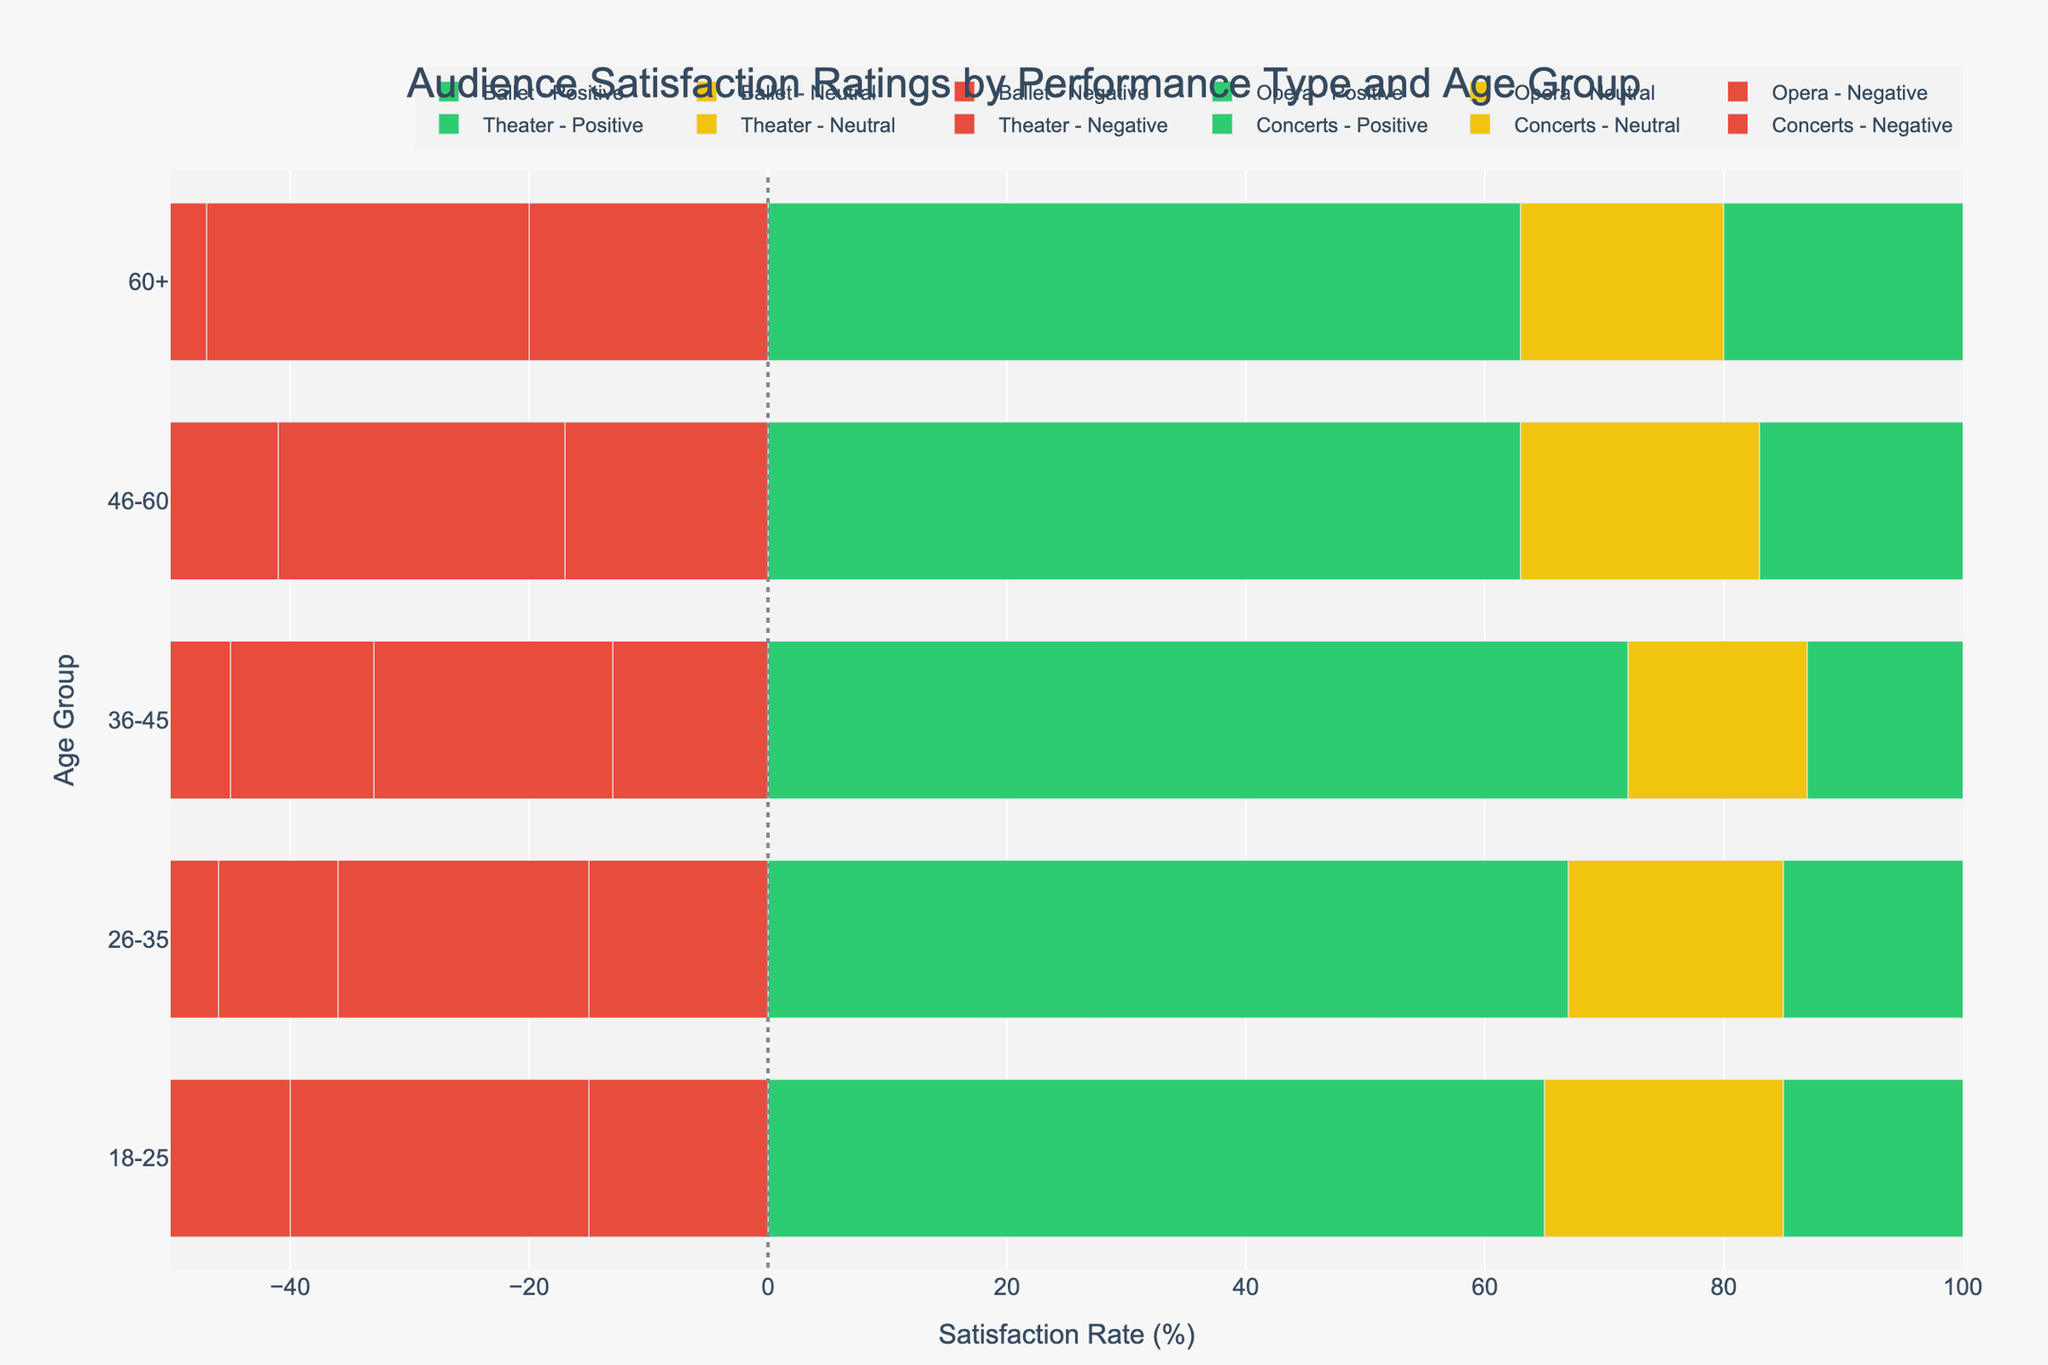Which age group has the highest satisfaction rate for concerts? The highest satisfaction rate is calculated by summing the "Satisfied" and "Very Satisfied" percentages. For the concerts category, we check each age group as follows:
- 18-25: 38 + 35 = 73%
- 26-35: 41 + 38 = 79%
- 36-45: 40 + 36 = 76%
- 46-60: 34 + 42 = 76%
- 60+: 30 + 40 = 70%
Hence, the 26-35 age group has the highest satisfaction rate for concerts.
Answer: 26-35 Which age group shows the most neutral response towards ballet performances? Look at the "Neutral" bars for ballet performances across all age groups:
- 18-25: 20
- 26-35: 18
- 36-45: 15
- 46-60: 20
- 60+: 17
The 18-25 and 46-60 age groups both show the highest neutral response with a value of 20.
Answer: 18-25 and 46-60 Compare the dissatisfaction rates (Very Dissatisfied + Dissatisfied) for opera performances between the age groups 18-25 and 60+. Which age group has higher dissatisfaction? We need to sum "Very Dissatisfied" and "Dissatisfied" percentages:
- 18-25: 10 + 15 = 25%
- 60+: 12 + 15 = 27%
The age group 60+ has a higher dissatisfaction rate for opera performances.
Answer: 60+ What is the average satisfaction rate (Satisfied + Very Satisfied) for theater performances across all age groups? Sum the "Satisfied" and "Very Satisfied" percentages for theater performances for each age group and find the average:
- 18-25: 35 + 39 = 74%
- 26-35: 34 + 39 = 73%
- 36-45: 37 + 37 = 74%
- 46-60: 32 + 36 = 68%
- 60+: 29 + 36 = 65%
Average satisfaction rate = (74 + 73 + 74 + 68 + 65) / 5 = 70.8%
Answer: 70.8% Which performance type has the smallest overall neutral response in the 26-35 age group? Check the "Neutral" bars for each performance type in the 26-35 age group:
- Ballet: 18
- Opera: 22
- Theater: 17
- Concerts: 13
Concerts have the smallest overall neutral response in the 26-35 age group.
Answer: Concerts Is the negative response (Very Dissatisfied + Dissatisfied) higher for ballet or opera performances in the 46-60 age group? Sum "Very Dissatisfied" and "Dissatisfied" for ballet and opera:
- Ballet: 7 + 10 = 17%
- Opera: 10 + 14 = 24%
The negative response is higher for opera performances in the 46-60 age group.
Answer: Opera In the 36-45 age group, which performance type has the largest difference between satisfied (Satisfied + Very Satisfied) and dissatisfied (Very Dissatisfied + Dissatisfied) rates? Calculate the differences:
- Ballet: (35 + 37) - (5 + 8) = 72 - 13 = 59%
- Opera: (33 + 29) - (8 + 12) = 62 - 20 = 42%
- Theater: (37 + 37) - (3 + 9) = 74 - 12 = 62%
- Concerts: (40 + 36) - (2 + 5) = 76 - 7 = 69%
Concerts have the largest difference with 69%.
Answer: Concerts 